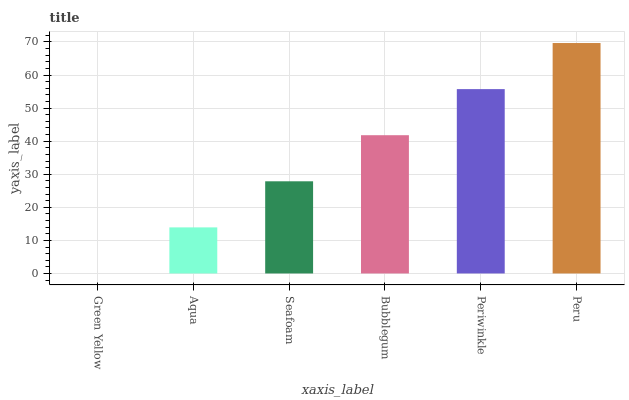Is Green Yellow the minimum?
Answer yes or no. Yes. Is Peru the maximum?
Answer yes or no. Yes. Is Aqua the minimum?
Answer yes or no. No. Is Aqua the maximum?
Answer yes or no. No. Is Aqua greater than Green Yellow?
Answer yes or no. Yes. Is Green Yellow less than Aqua?
Answer yes or no. Yes. Is Green Yellow greater than Aqua?
Answer yes or no. No. Is Aqua less than Green Yellow?
Answer yes or no. No. Is Bubblegum the high median?
Answer yes or no. Yes. Is Seafoam the low median?
Answer yes or no. Yes. Is Green Yellow the high median?
Answer yes or no. No. Is Aqua the low median?
Answer yes or no. No. 